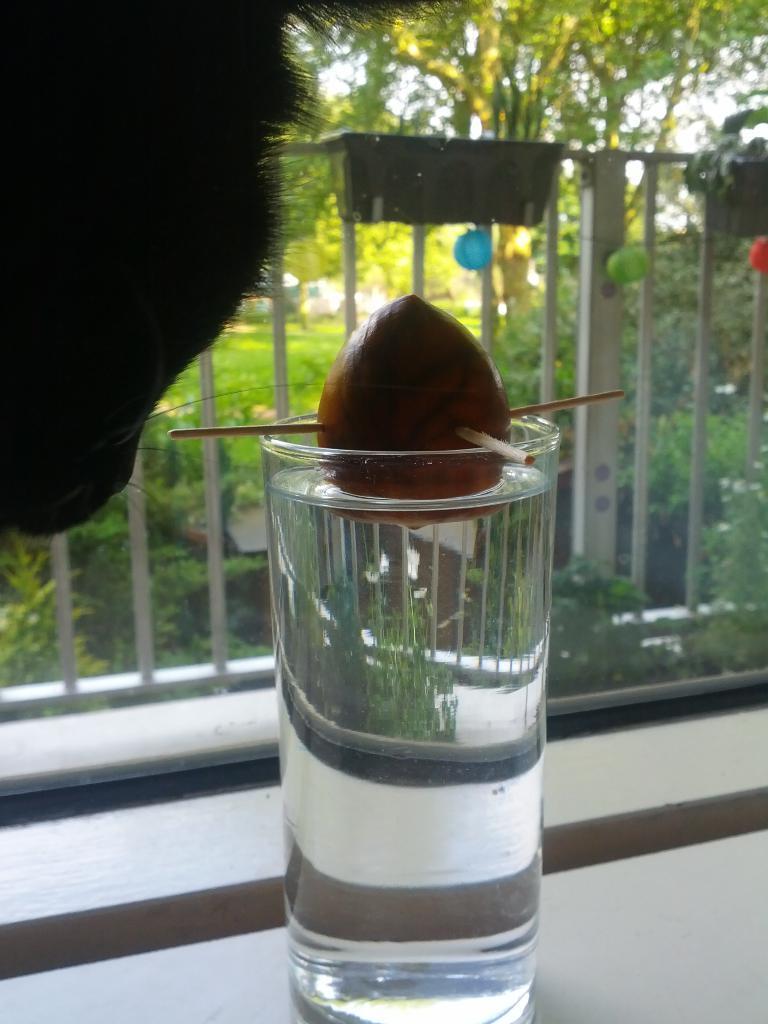Please provide a concise description of this image. Here I can see a glass filled with the water and an object is placed on that which is looking like a fruit. On the left side, I can see a person's head. In the background there is a railing. At the back of it I can see many plants and trees. 